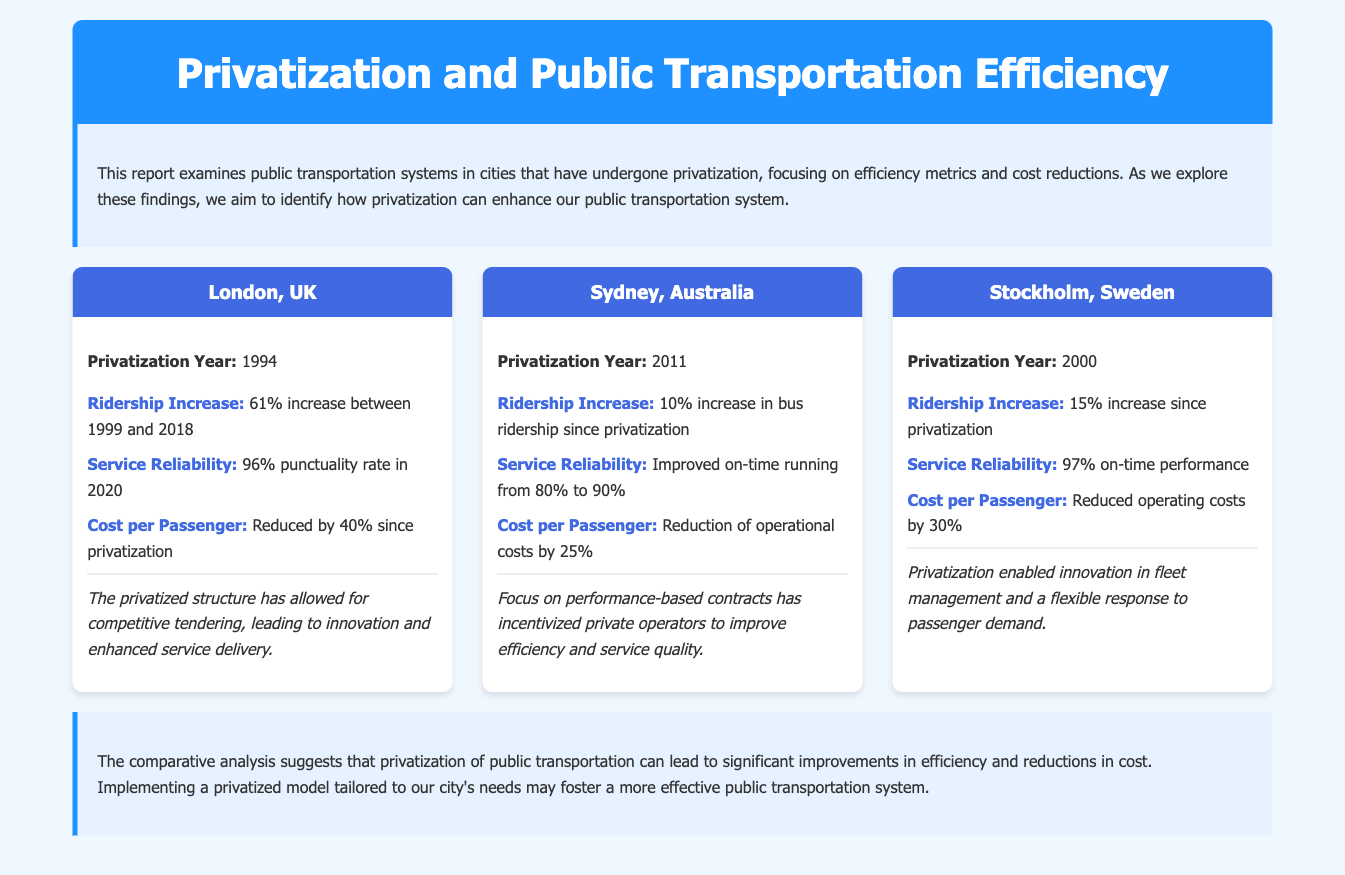what year did London undergo privatization? The document states that London underwent privatization in 1994.
Answer: 1994 what was the ridership increase in London from 1999 to 2018? According to the document, there was a 61% increase in ridership in London during that period.
Answer: 61% how much did the cost per passenger reduce in Sydney after privatization? The document mentions that the cost per passenger in Sydney reduced by 25% after privatization.
Answer: 25% what is the service reliability rate in Stockholm? The document indicates that Stockholm has a 97% on-time performance rate.
Answer: 97% what has been the impact on bus ridership in Sydney since privatization? The document states there has been a 10% increase in bus ridership in Sydney since privatization.
Answer: 10% how much has operational costs reduced in London since privatization? The document expresses that operational costs in London have been reduced by 40% since privatization.
Answer: 40% what common result was found across all three cities? The document describes that all cities experienced increases in ridership post-privatization.
Answer: Increases in ridership what is the focus of performance-based contracts in Sydney? The document notes that performance-based contracts incentivized private operators to improve efficiency and service quality.
Answer: Improve efficiency and service quality what aspect of public transportation did Stockholm improve through privatization? The document suggests that privatization in Stockholm enabled innovation in fleet management.
Answer: Innovation in fleet management 